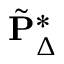<formula> <loc_0><loc_0><loc_500><loc_500>\tilde { P } _ { \Delta } ^ { \ast }</formula> 